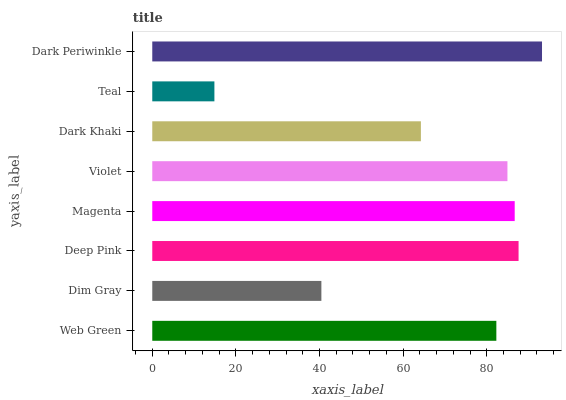Is Teal the minimum?
Answer yes or no. Yes. Is Dark Periwinkle the maximum?
Answer yes or no. Yes. Is Dim Gray the minimum?
Answer yes or no. No. Is Dim Gray the maximum?
Answer yes or no. No. Is Web Green greater than Dim Gray?
Answer yes or no. Yes. Is Dim Gray less than Web Green?
Answer yes or no. Yes. Is Dim Gray greater than Web Green?
Answer yes or no. No. Is Web Green less than Dim Gray?
Answer yes or no. No. Is Violet the high median?
Answer yes or no. Yes. Is Web Green the low median?
Answer yes or no. Yes. Is Dim Gray the high median?
Answer yes or no. No. Is Teal the low median?
Answer yes or no. No. 